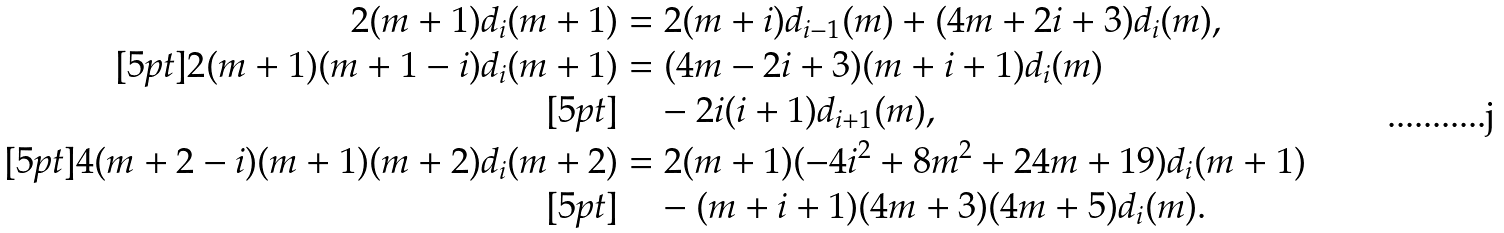Convert formula to latex. <formula><loc_0><loc_0><loc_500><loc_500>2 ( m + 1 ) d _ { i } ( m + 1 ) & = 2 ( m + i ) d _ { i - 1 } ( m ) + ( 4 m + 2 i + 3 ) d _ { i } ( m ) , \\ [ 5 p t ] 2 ( m + 1 ) ( m + 1 - i ) d _ { i } ( m + 1 ) & = ( 4 m - 2 i + 3 ) ( m + i + 1 ) d _ { i } ( m ) \\ [ 5 p t ] & \quad - 2 i ( i + 1 ) d _ { i + 1 } ( m ) , \\ [ 5 p t ] 4 ( m + 2 - i ) ( m + 1 ) ( m + 2 ) d _ { i } ( m + 2 ) & = 2 ( m + 1 ) ( - 4 i ^ { 2 } + 8 m ^ { 2 } + 2 4 m + 1 9 ) d _ { i } ( m + 1 ) \\ [ 5 p t ] & \quad - ( m + i + 1 ) ( 4 m + 3 ) ( 4 m + 5 ) d _ { i } ( m ) .</formula> 